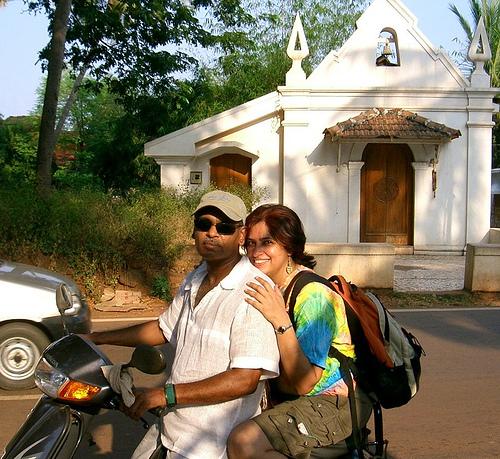Is there a bell on the building?
Write a very short answer. Yes. What are they riding on?
Give a very brief answer. Motorcycle. What type of building are they at?
Be succinct. Church. 